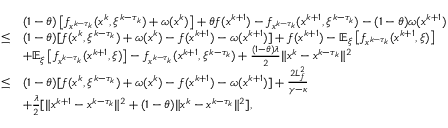<formula> <loc_0><loc_0><loc_500><loc_500>\begin{array} { r l } & { ( 1 - \theta ) \left [ f _ { x ^ { k - \tau _ { k } } } ( x ^ { k } , \xi ^ { k - \tau _ { k } } ) + \omega ( x ^ { k } ) \right ] + \theta f ( x ^ { k + 1 } ) - f _ { x ^ { k - \tau _ { k } } } ( x ^ { k + 1 } , \xi ^ { k - \tau _ { k } } ) - ( 1 - \theta ) \omega ( x ^ { k + 1 } ) } \\ { \leq } & { ( 1 - \theta ) [ f ( x ^ { k } , \xi ^ { k - \tau _ { k } } ) + \omega ( x ^ { k } ) - f ( x ^ { k + 1 } ) - \omega ( x ^ { k + 1 } ) ] + f ( x ^ { k + 1 } ) - \mathbb { E } _ { \xi } \left [ f _ { x ^ { k - \tau _ { k } } } ( x ^ { k + 1 } , \xi ) \right ] } \\ & { + \mathbb { E } _ { \xi } \left [ f _ { x ^ { k - \tau _ { k } } } ( x ^ { k + 1 } , \xi ) \right ] - f _ { x ^ { k - \tau _ { k } } } ( x ^ { k + 1 } , \xi ^ { k - \tau _ { k } } ) + \frac { ( 1 - \theta ) \lambda } { 2 } \| x ^ { k } - x ^ { k - \tau _ { k } } \| ^ { 2 } } \\ { \leq } & { ( 1 - \theta ) [ f ( x ^ { k } , \xi ^ { k - \tau _ { k } } ) + \omega ( x ^ { k } ) - f ( x ^ { k + 1 } ) - \omega ( x ^ { k + 1 } ) ] + \frac { 2 L _ { f } ^ { 2 } } { \gamma - \kappa } } \\ & { + \frac { \lambda } { 2 } [ \| x ^ { k + 1 } - x ^ { k - \tau _ { k } } \| ^ { 2 } + ( 1 - \theta ) \| x ^ { k } - x ^ { k - \tau _ { k } } \| ^ { 2 } ] , } \end{array}</formula> 